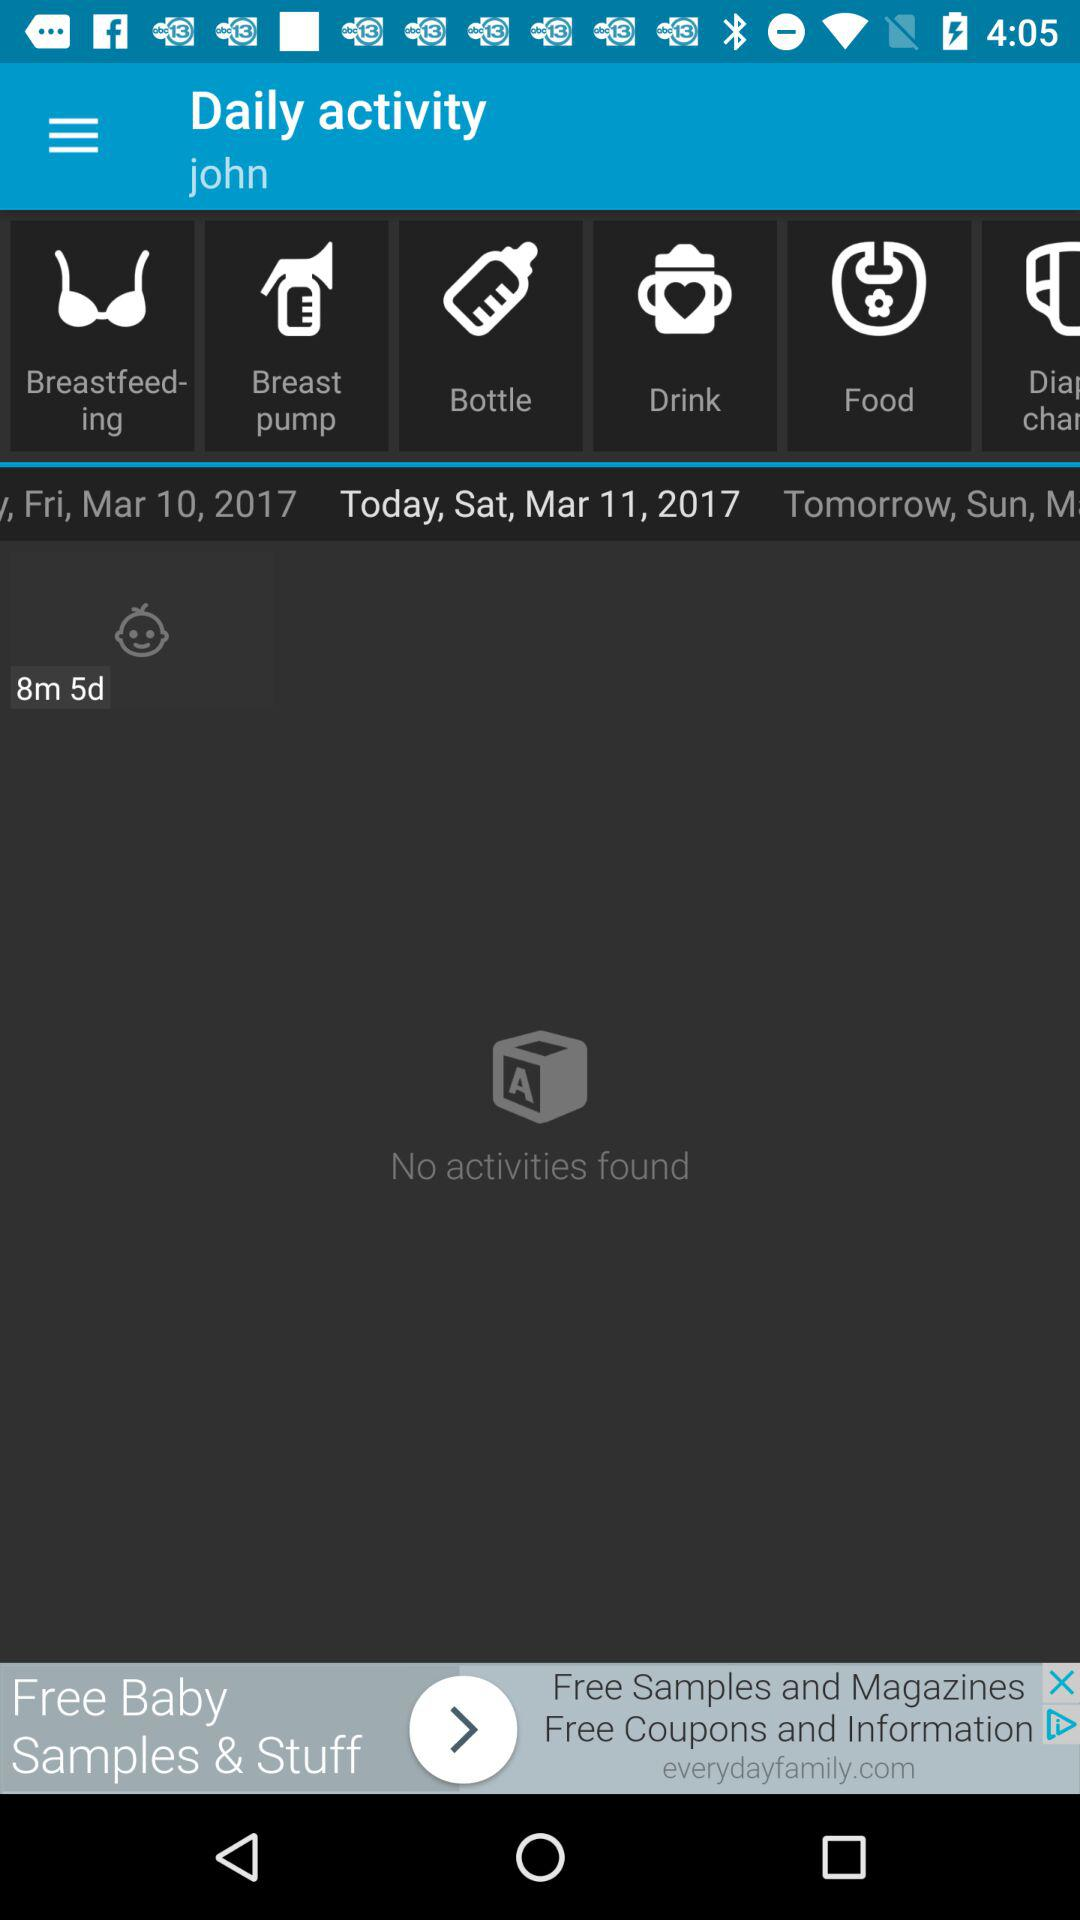Which day is March 10, 2017? The day is Friday. 